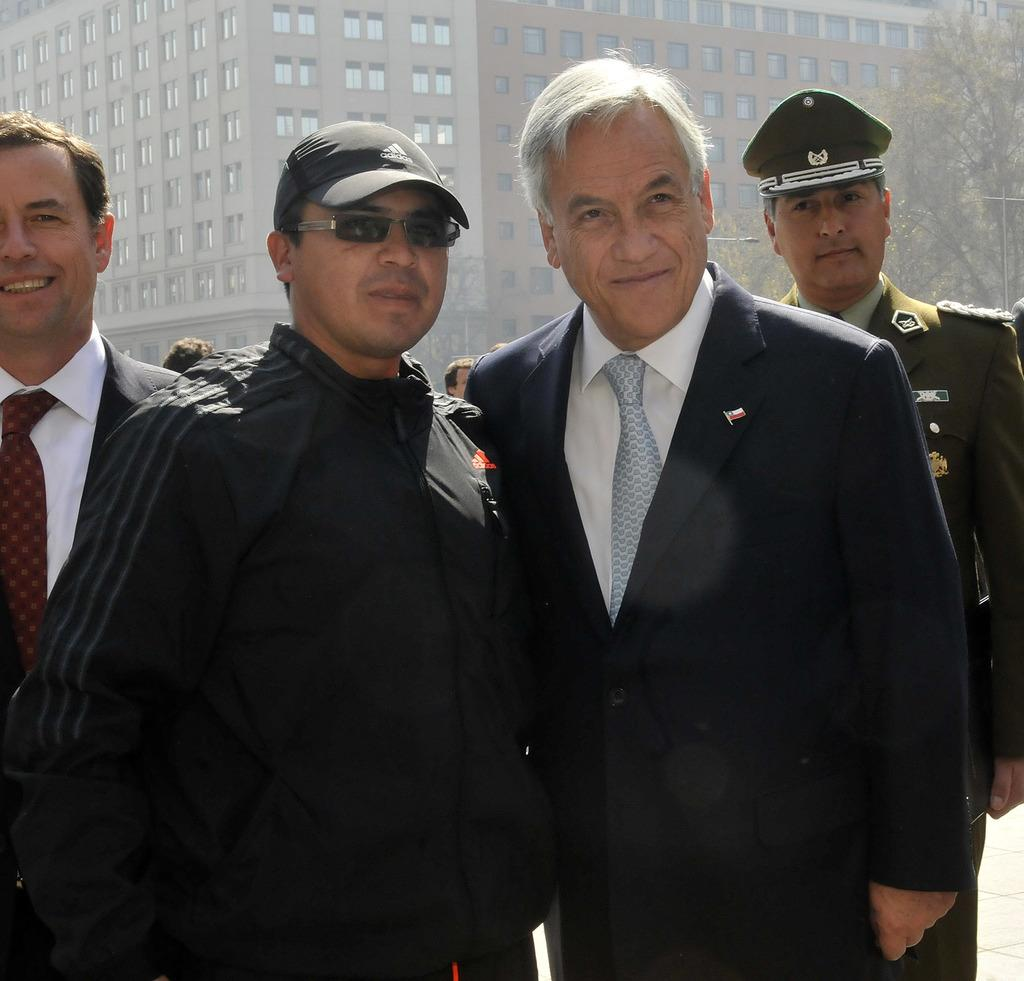How many men are present in the image? There are four men standing in the image. What is the facial expression of the men? The men are smiling. Can you describe the background of the image? There are people, trees, a pole, a light, a building, and windows visible in the background of the image. What type of bun is being used to mark the route in the image? There is no bun or route present in the image; it features four men standing with a background of people, trees, a pole, a light, a building, and windows. 